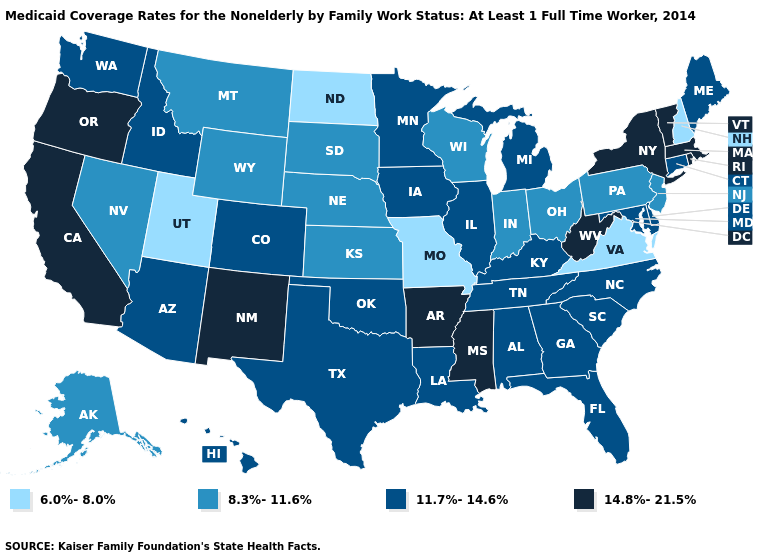Does Arkansas have a higher value than New Mexico?
Answer briefly. No. What is the lowest value in the MidWest?
Write a very short answer. 6.0%-8.0%. Does Wyoming have the highest value in the West?
Write a very short answer. No. What is the value of Alabama?
Give a very brief answer. 11.7%-14.6%. What is the value of Wyoming?
Keep it brief. 8.3%-11.6%. Which states have the highest value in the USA?
Answer briefly. Arkansas, California, Massachusetts, Mississippi, New Mexico, New York, Oregon, Rhode Island, Vermont, West Virginia. Name the states that have a value in the range 14.8%-21.5%?
Concise answer only. Arkansas, California, Massachusetts, Mississippi, New Mexico, New York, Oregon, Rhode Island, Vermont, West Virginia. Does the map have missing data?
Keep it brief. No. Does Utah have the lowest value in the West?
Keep it brief. Yes. Which states have the lowest value in the USA?
Give a very brief answer. Missouri, New Hampshire, North Dakota, Utah, Virginia. Does Wisconsin have the same value as Pennsylvania?
Quick response, please. Yes. What is the value of Texas?
Answer briefly. 11.7%-14.6%. What is the value of Wyoming?
Be succinct. 8.3%-11.6%. Does Virginia have the lowest value in the South?
Be succinct. Yes. 